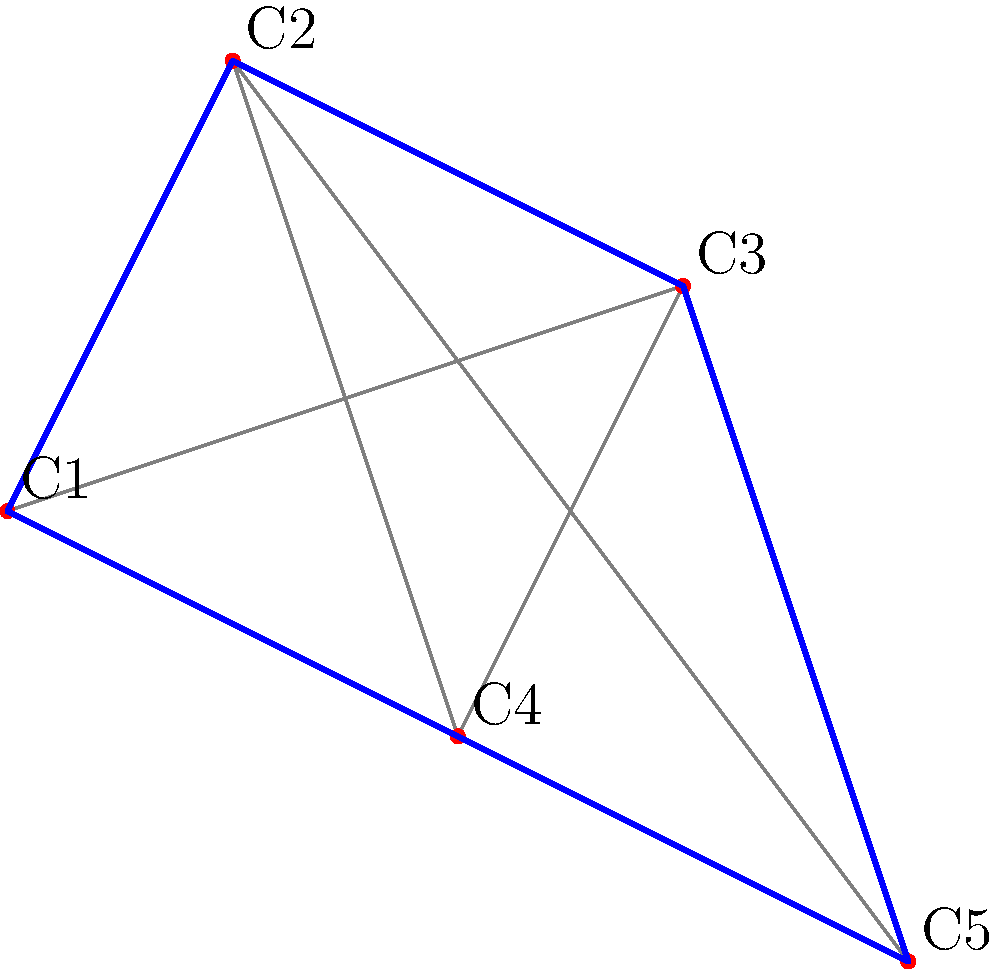As the organizer of a mobile art exhibition in Toronto, you need to plan the most efficient route to visit 5 community centers. The distances between centers are given in kilometers: C1-C2: 3, C1-C3: 4, C1-C4: 3, C1-C5: 5, C2-C3: 2, C2-C4: 4, C2-C5: 6, C3-C4: 3, C3-C5: 3, C4-C5: 2. What is the total distance of the shortest route that visits all centers exactly once and returns to the starting point? To solve this traveling salesman problem, we'll use the nearest neighbor heuristic:

1. Start at C1 (arbitrarily chosen).
2. Find the nearest unvisited center:
   - C1 to C2 or C4 (both 3 km). Choose C2.
3. From C2, find the nearest unvisited center:
   - C2 to C3 (2 km).
4. From C3, find the nearest unvisited center:
   - C3 to C5 (3 km).
5. From C5, the only unvisited center is C4 (2 km).
6. Return to C1 from C4 (3 km).

The route is: C1 → C2 → C3 → C5 → C4 → C1

Total distance: 3 + 2 + 3 + 2 + 3 = 13 km

Note: This heuristic doesn't always find the optimal solution, but it's efficient and often provides a good approximation.
Answer: 13 km 